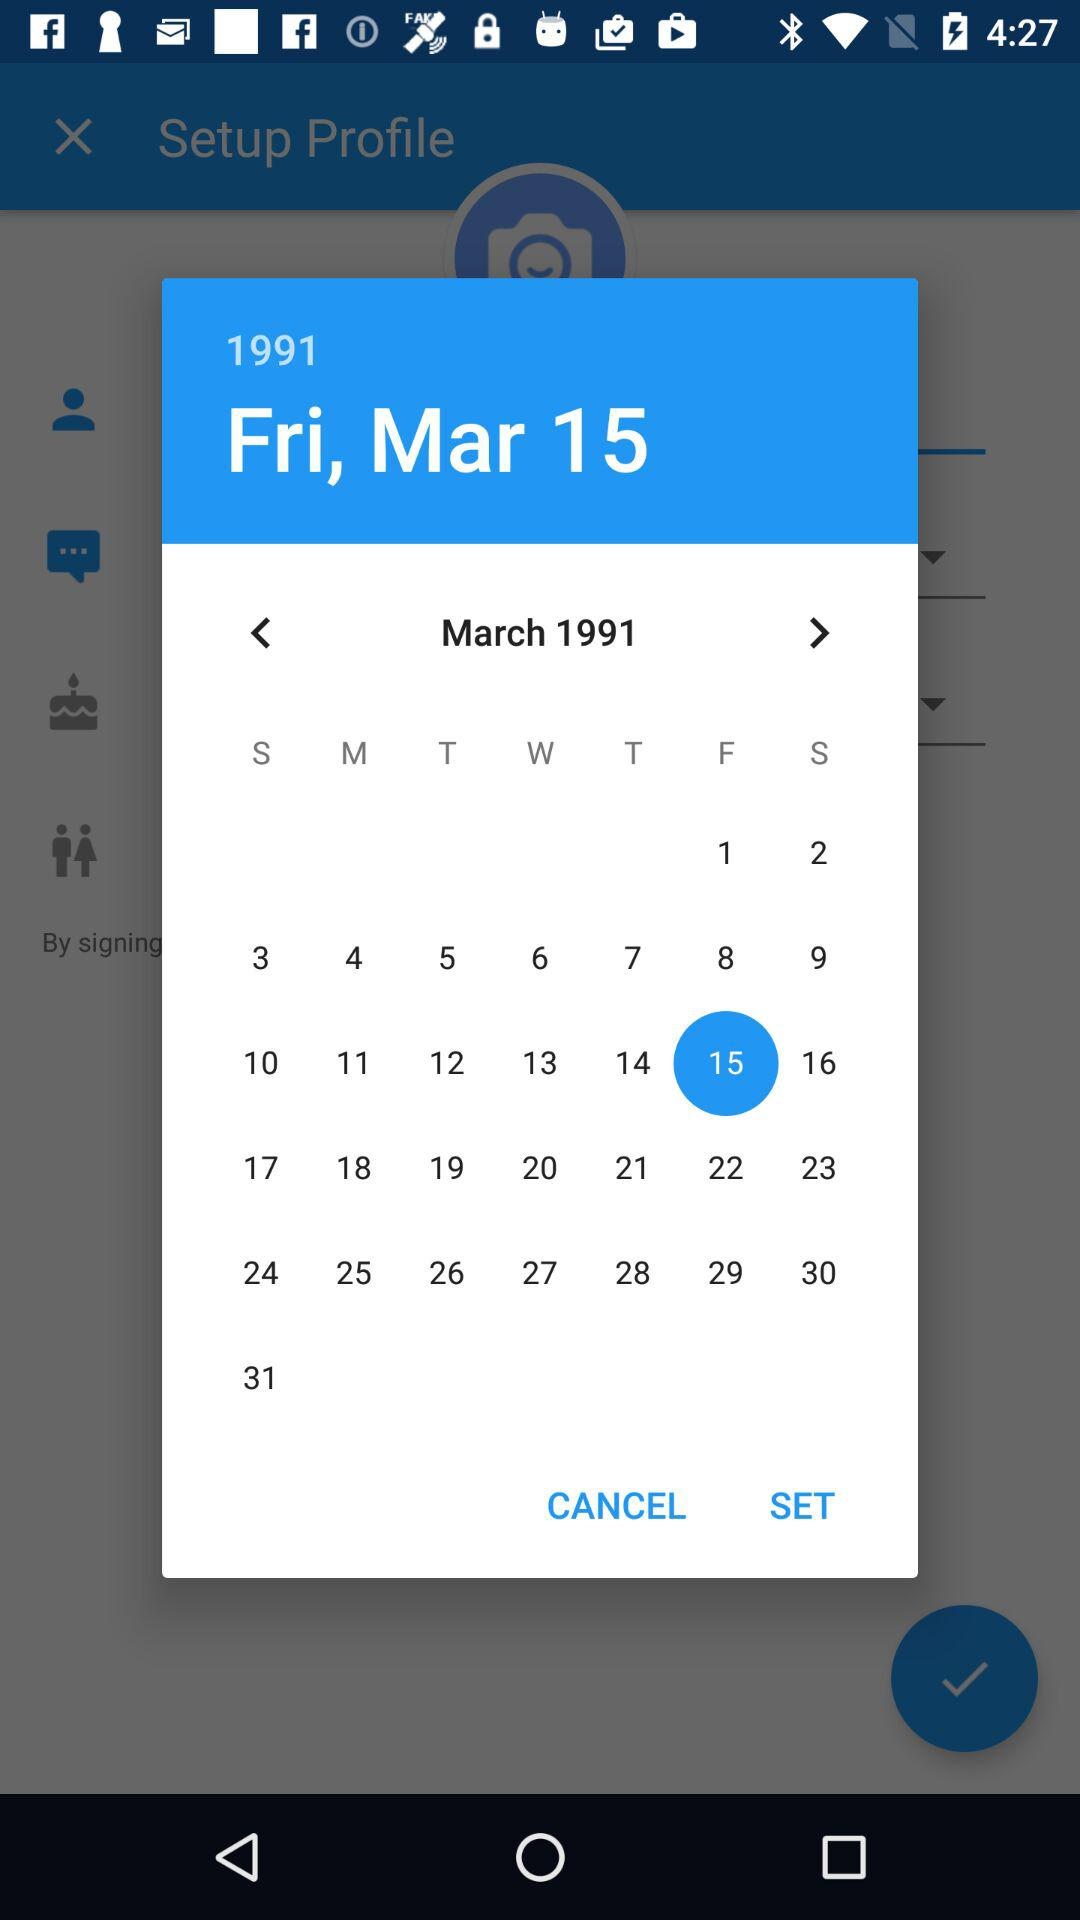Which day falls on the 30th of March 1991? The day that falls on the 30th of March 1991 is a Saturday. 